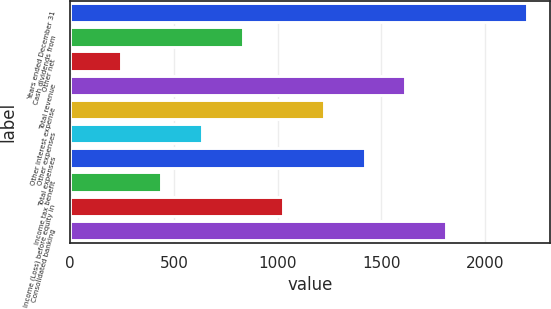Convert chart to OTSL. <chart><loc_0><loc_0><loc_500><loc_500><bar_chart><fcel>Years ended December 31<fcel>Cash dividends from<fcel>Other net<fcel>Total revenue<fcel>Other interest expense<fcel>Other expenses<fcel>Total expenses<fcel>Income tax benefit<fcel>Income (Loss) before equity in<fcel>Consolidated banking<nl><fcel>2202.9<fcel>831.6<fcel>243.9<fcel>1615.2<fcel>1223.4<fcel>635.7<fcel>1419.3<fcel>439.8<fcel>1027.5<fcel>1811.1<nl></chart> 